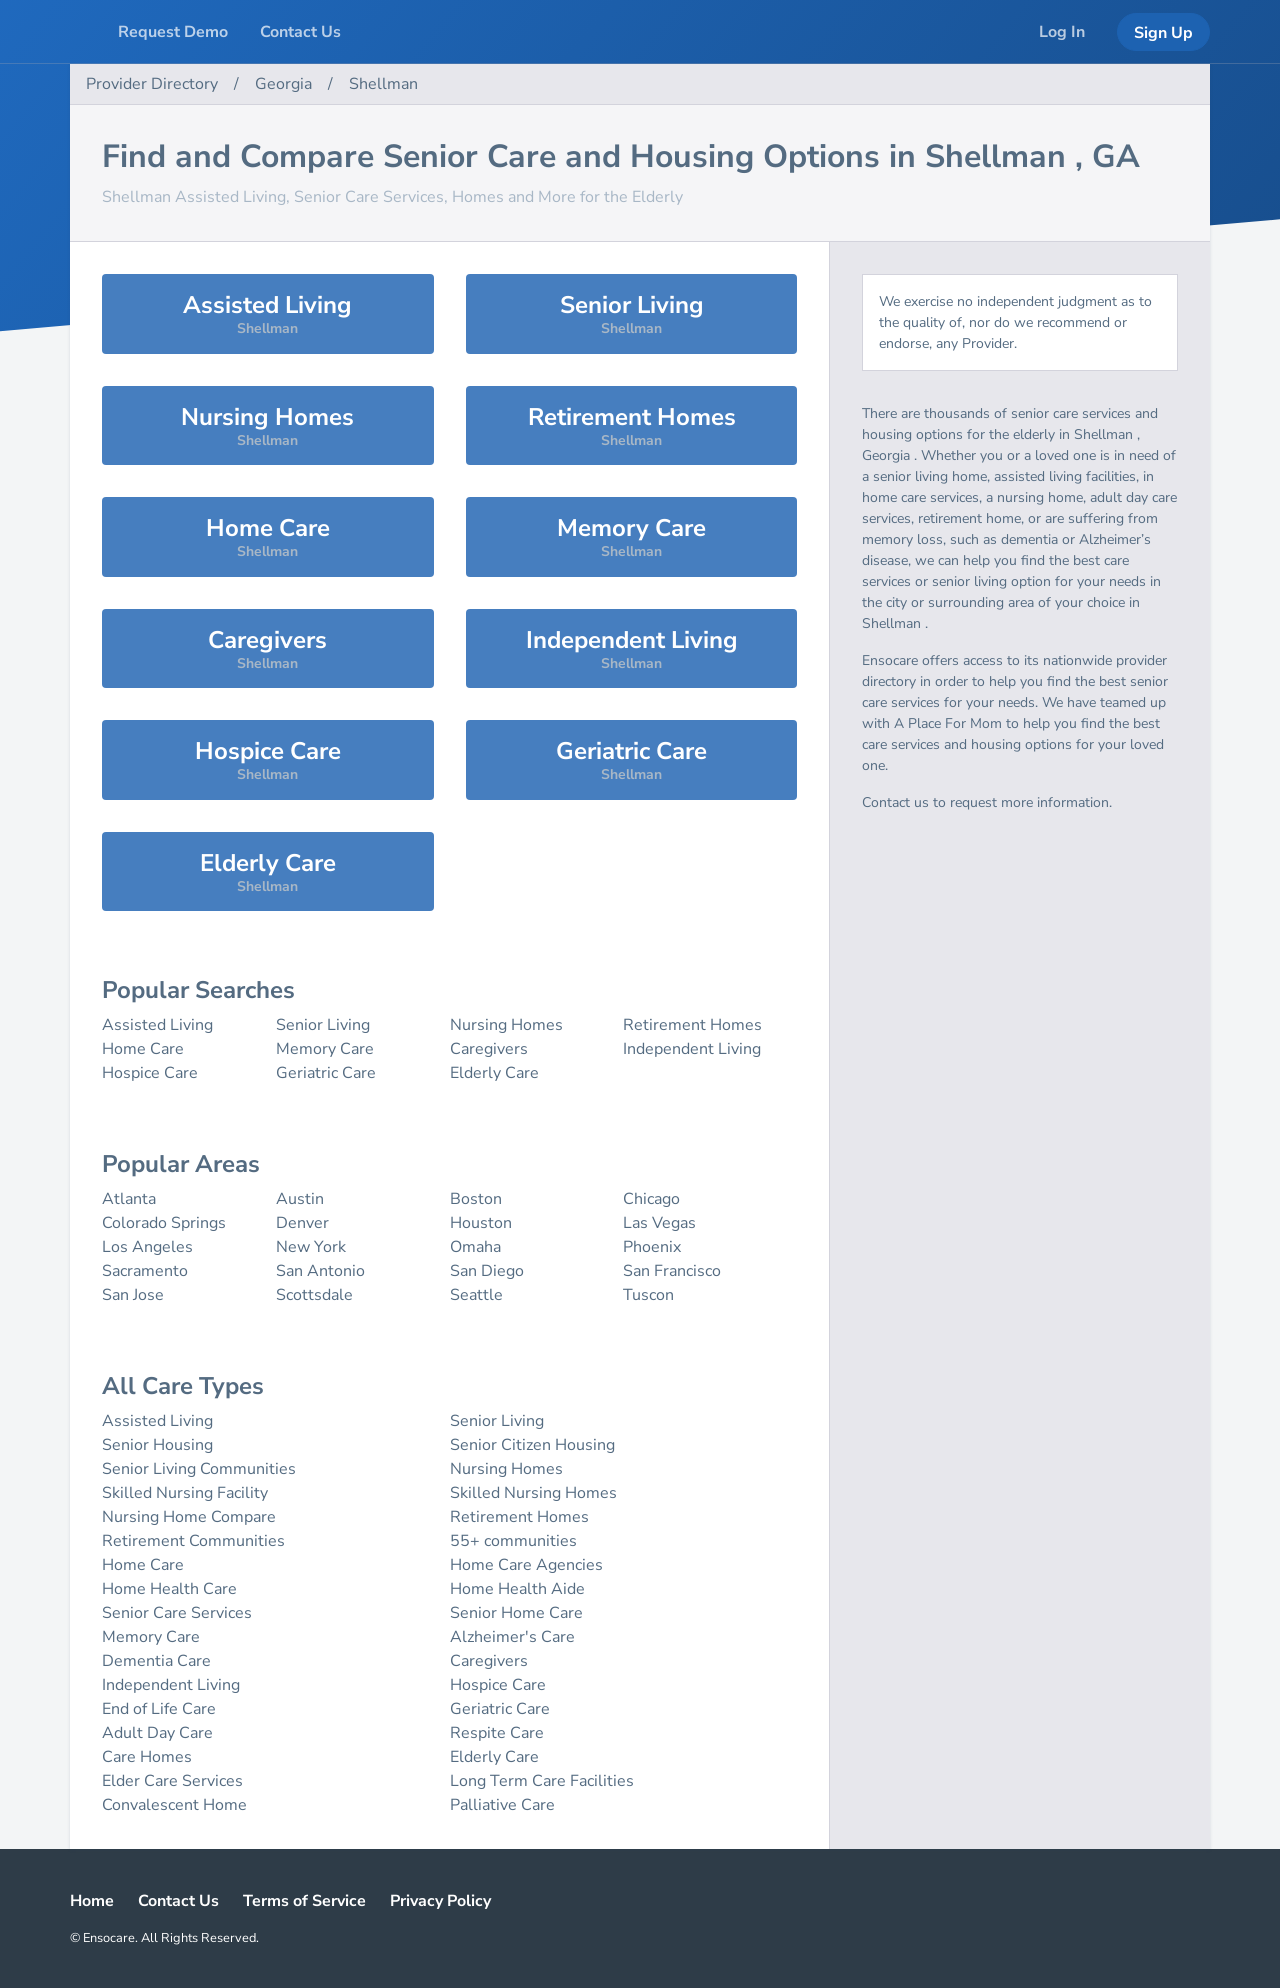What's the procedure for constructing this website from scratch with HTML? To construct a website from scratch using HTML, start by declaring the document type and defining the structure of the webpage. Include the DOCTYPE declaration at the top, which helps the browser to display the webpage correctly. Use the <html> tag to wrap the entire content. Within the <html> element, include a <head> section where you define metadata, link stylesheets, and set the title of the webpage. Finally, create the <body> section where you place all the visible content elements like headers, paragraphs, images, and links. Here's a simple template:

<!DOCTYPE html>
<html>
  <head>
    <title>Your Website Title Here</title>
    <!-- Link to external CSS file -->
    <link rel='stylesheet' type='text/css' href='styles.css'>
  </head>
  <body>
    <h1>Welcome to My Website</h1>
    <p>This is a paragraph of text on my webpage.</p>
    <!-- Additional content goes here -->
  </body>
</html>

This structure forms the basic skeleton of your webpage, which you can then expand upon with more HTML elements and attributes to add complexity and functionality. 